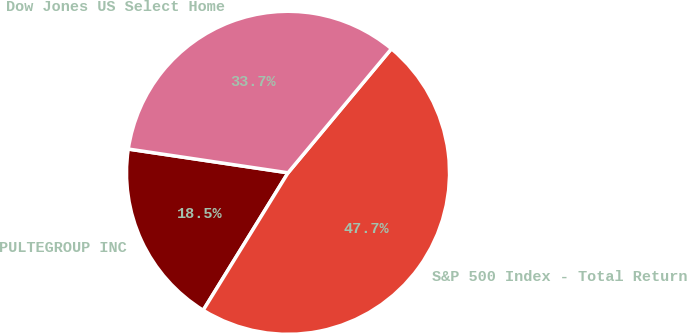<chart> <loc_0><loc_0><loc_500><loc_500><pie_chart><fcel>PULTEGROUP INC<fcel>S&P 500 Index - Total Return<fcel>Dow Jones US Select Home<nl><fcel>18.55%<fcel>47.74%<fcel>33.71%<nl></chart> 